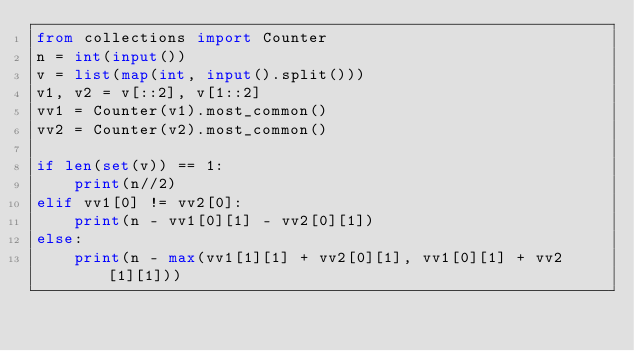<code> <loc_0><loc_0><loc_500><loc_500><_Python_>from collections import Counter
n = int(input())
v = list(map(int, input().split()))
v1, v2 = v[::2], v[1::2]
vv1 = Counter(v1).most_common()
vv2 = Counter(v2).most_common()

if len(set(v)) == 1:
    print(n//2)
elif vv1[0] != vv2[0]:
    print(n - vv1[0][1] - vv2[0][1])
else:
    print(n - max(vv1[1][1] + vv2[0][1], vv1[0][1] + vv2[1][1]))</code> 